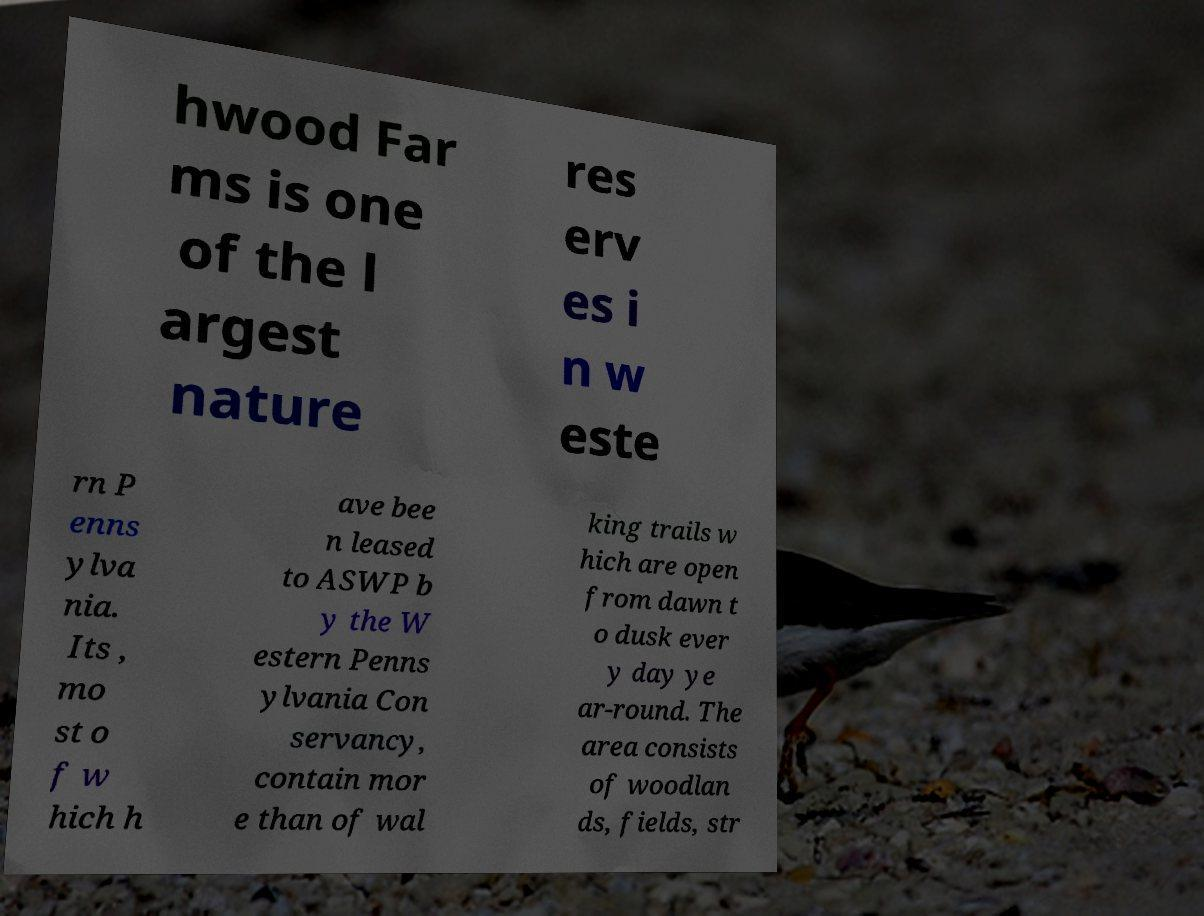For documentation purposes, I need the text within this image transcribed. Could you provide that? hwood Far ms is one of the l argest nature res erv es i n w este rn P enns ylva nia. Its , mo st o f w hich h ave bee n leased to ASWP b y the W estern Penns ylvania Con servancy, contain mor e than of wal king trails w hich are open from dawn t o dusk ever y day ye ar-round. The area consists of woodlan ds, fields, str 